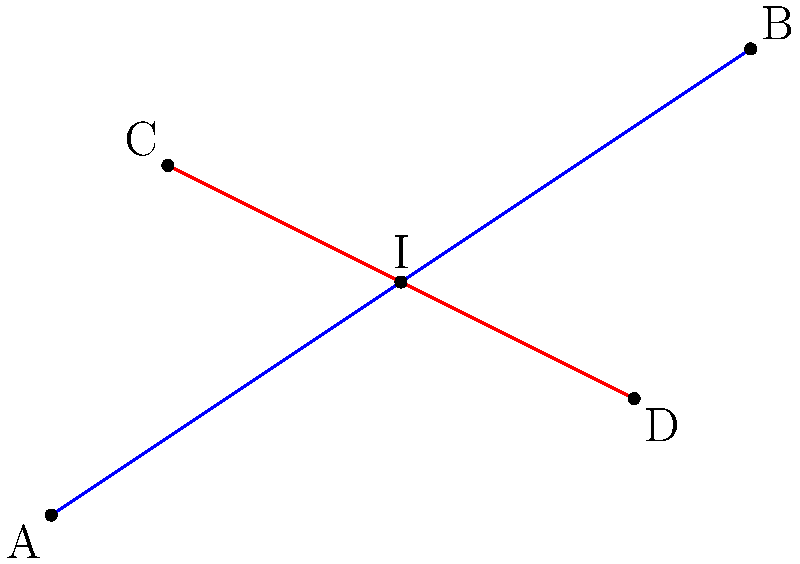Given two line segments AB and CD in a 2D coordinate system, where A(0,0), B(6,4), C(1,3), and D(5,1), calculate the coordinates of the intersection point I. Round your answer to two decimal places. To find the intersection point of two line segments, we can follow these steps:

1) First, let's write the equations of both lines in the form $y = mx + b$:

   For line AB: $m_1 = \frac{4-0}{6-0} = \frac{2}{3}$, $b_1 = 0$
   Equation: $y = \frac{2}{3}x$

   For line CD: $m_2 = \frac{1-3}{5-1} = -\frac{1}{2}$, $b_2 = 4$
   Equation: $y = -\frac{1}{2}x + 4$

2) To find the intersection point, we set these equations equal to each other:

   $\frac{2}{3}x = -\frac{1}{2}x + 4$

3) Solve for x:

   $\frac{2}{3}x + \frac{1}{2}x = 4$
   $\frac{4}{6}x + \frac{3}{6}x = 4$
   $\frac{7}{6}x = 4$
   $x = \frac{24}{7} \approx 3.43$

4) Substitute this x-value back into either of the original equations to find y:

   $y = \frac{2}{3}(3.43) \approx 2.29$

5) Therefore, the intersection point I is approximately (3.43, 2.29).
Answer: (3.43, 2.29) 